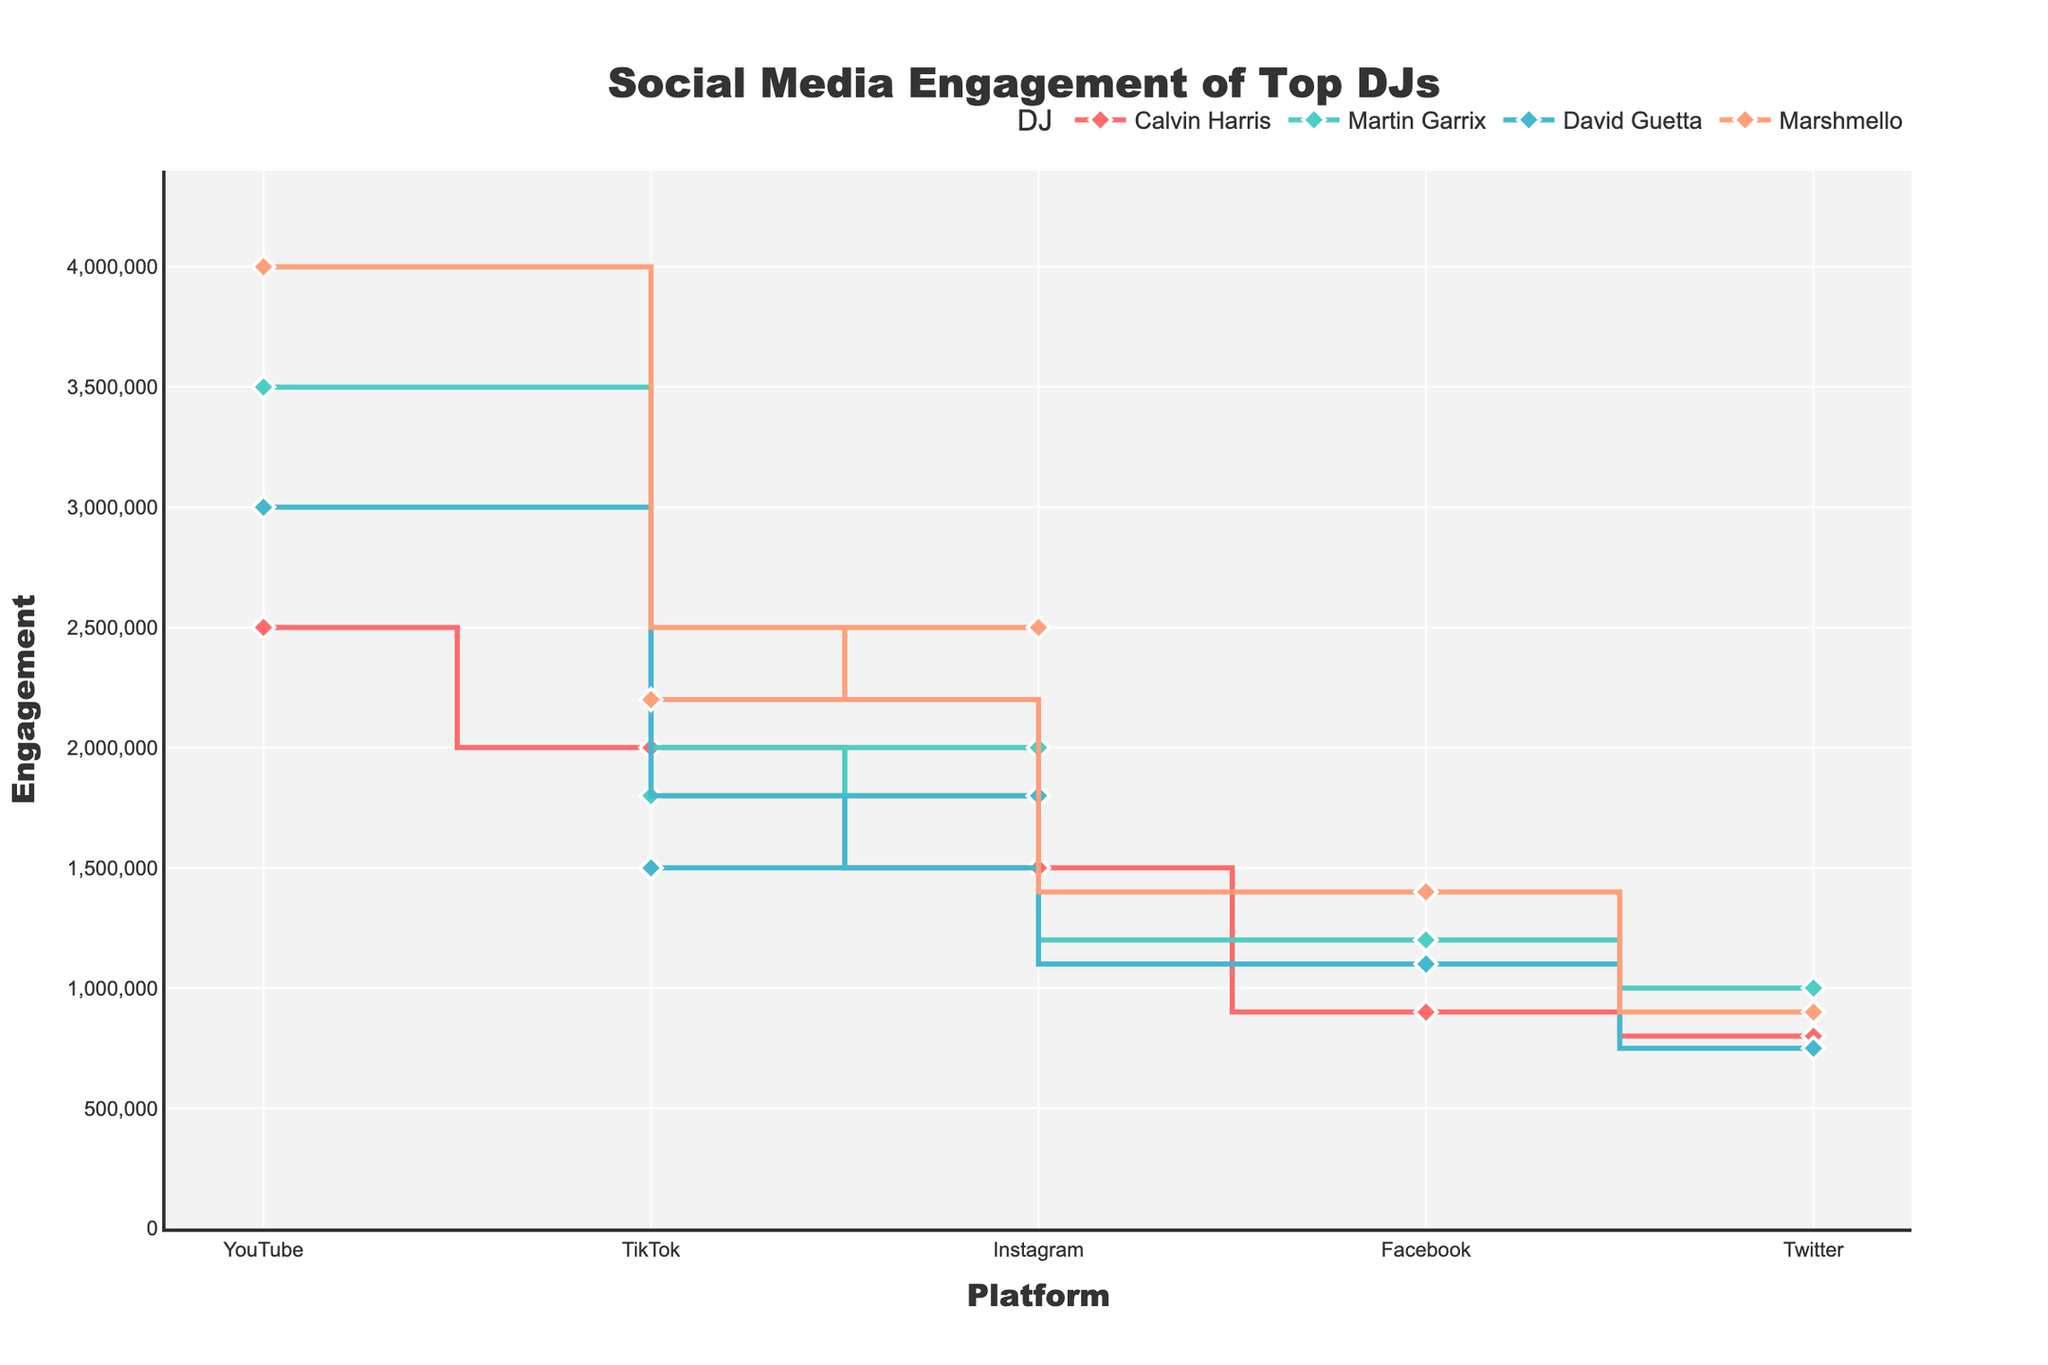What's the title of the figure? The title of the figure is typically displayed prominently at the top and provides the main subject of the chart.
Answer: Social Media Engagement of Top DJs How many social media platforms are shown in the plot? By counting the unique platforms listed on the x-axis of the figure, we find there are five platforms.
Answer: Five Which DJ has the highest engagement on YouTube? The figure plots the engagement values of different DJs across platforms. By looking for the tallest point in the YouTube section and identifying the DJ associated with it, we see Marshmello has the highest engagement on YouTube.
Answer: Marshmello What's the engagement difference between Martin Garrix's Instagram and TikTok? The engagement on Martin Garrix's Instagram is 2,000,000, and on TikTok, it is 1,800,000. Subtract the TikTok engagement from the Instagram engagement to find the difference: 2,000,000 - 1,800,000 = 200,000.
Answer: 200,000 Which DJ has the lowest engagement on Twitter? By identifying the shortest point in the Twitter section of the figure, which represents the engagement on Twitter for each DJ, we see that David Guetta has the lowest engagement on Twitter with 750,000.
Answer: David Guetta What is the average engagement across all platforms for Calvin Harris? Sum the engagement values for Calvin Harris across all platforms (1,500,000 + 800,000 + 900,000 + 2,500,000 + 2,000,000 = 7,700,000), then divide by the number of platforms (5): 7,700,000 / 5 = 1,540,000.
Answer: 1,540,000 Between David Guetta and Marshmello, who has higher engagement on Facebook? By comparing the heights of the points in the Facebook section for David Guetta (1,100,000) and Marshmello (1,400,000), Marshmello has higher engagement.
Answer: Marshmello What's the total engagement on TikTok for all DJs combined? Sum the engagement values on TikTok for each DJ: Calvin Harris (2,000,000) + Martin Garrix (1,800,000) + David Guetta (1,500,000) + Marshmello (2,200,000) = 7,500,000.
Answer: 7,500,000 